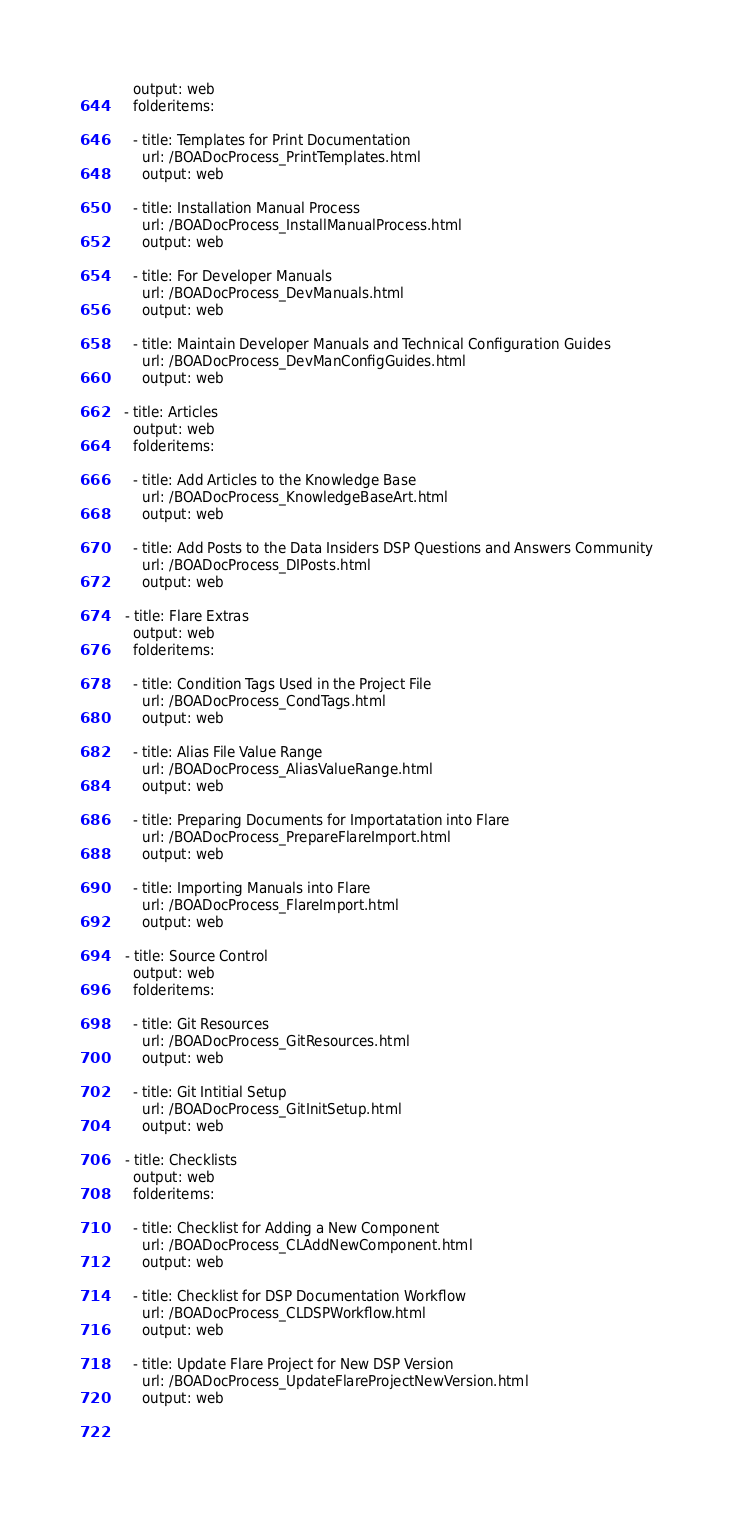Convert code to text. <code><loc_0><loc_0><loc_500><loc_500><_YAML_>    output: web
    folderitems:

    - title: Templates for Print Documentation
      url: /BOADocProcess_PrintTemplates.html
      output: web

    - title: Installation Manual Process
      url: /BOADocProcess_InstallManualProcess.html
      output: web

    - title: For Developer Manuals
      url: /BOADocProcess_DevManuals.html
      output: web

    - title: Maintain Developer Manuals and Technical Configuration Guides
      url: /BOADocProcess_DevManConfigGuides.html
      output: web

  - title: Articles
    output: web
    folderitems:

    - title: Add Articles to the Knowledge Base
      url: /BOADocProcess_KnowledgeBaseArt.html
      output: web

    - title: Add Posts to the Data Insiders DSP Questions and Answers Community
      url: /BOADocProcess_DIPosts.html
      output: web

  - title: Flare Extras
    output: web
    folderitems:

    - title: Condition Tags Used in the Project File
      url: /BOADocProcess_CondTags.html
      output: web

    - title: Alias File Value Range
      url: /BOADocProcess_AliasValueRange.html
      output: web

    - title: Preparing Documents for Importatation into Flare
      url: /BOADocProcess_PrepareFlareImport.html
      output: web

    - title: Importing Manuals into Flare
      url: /BOADocProcess_FlareImport.html
      output: web

  - title: Source Control
    output: web
    folderitems:

    - title: Git Resources
      url: /BOADocProcess_GitResources.html
      output: web

    - title: Git Intitial Setup
      url: /BOADocProcess_GitInitSetup.html
      output: web

  - title: Checklists
    output: web
    folderitems:

    - title: Checklist for Adding a New Component
      url: /BOADocProcess_CLAddNewComponent.html
      output: web

    - title: Checklist for DSP Documentation Workflow
      url: /BOADocProcess_CLDSPWorkflow.html
      output: web

    - title: Update Flare Project for New DSP Version
      url: /BOADocProcess_UpdateFlareProjectNewVersion.html
      output: web

      
</code> 